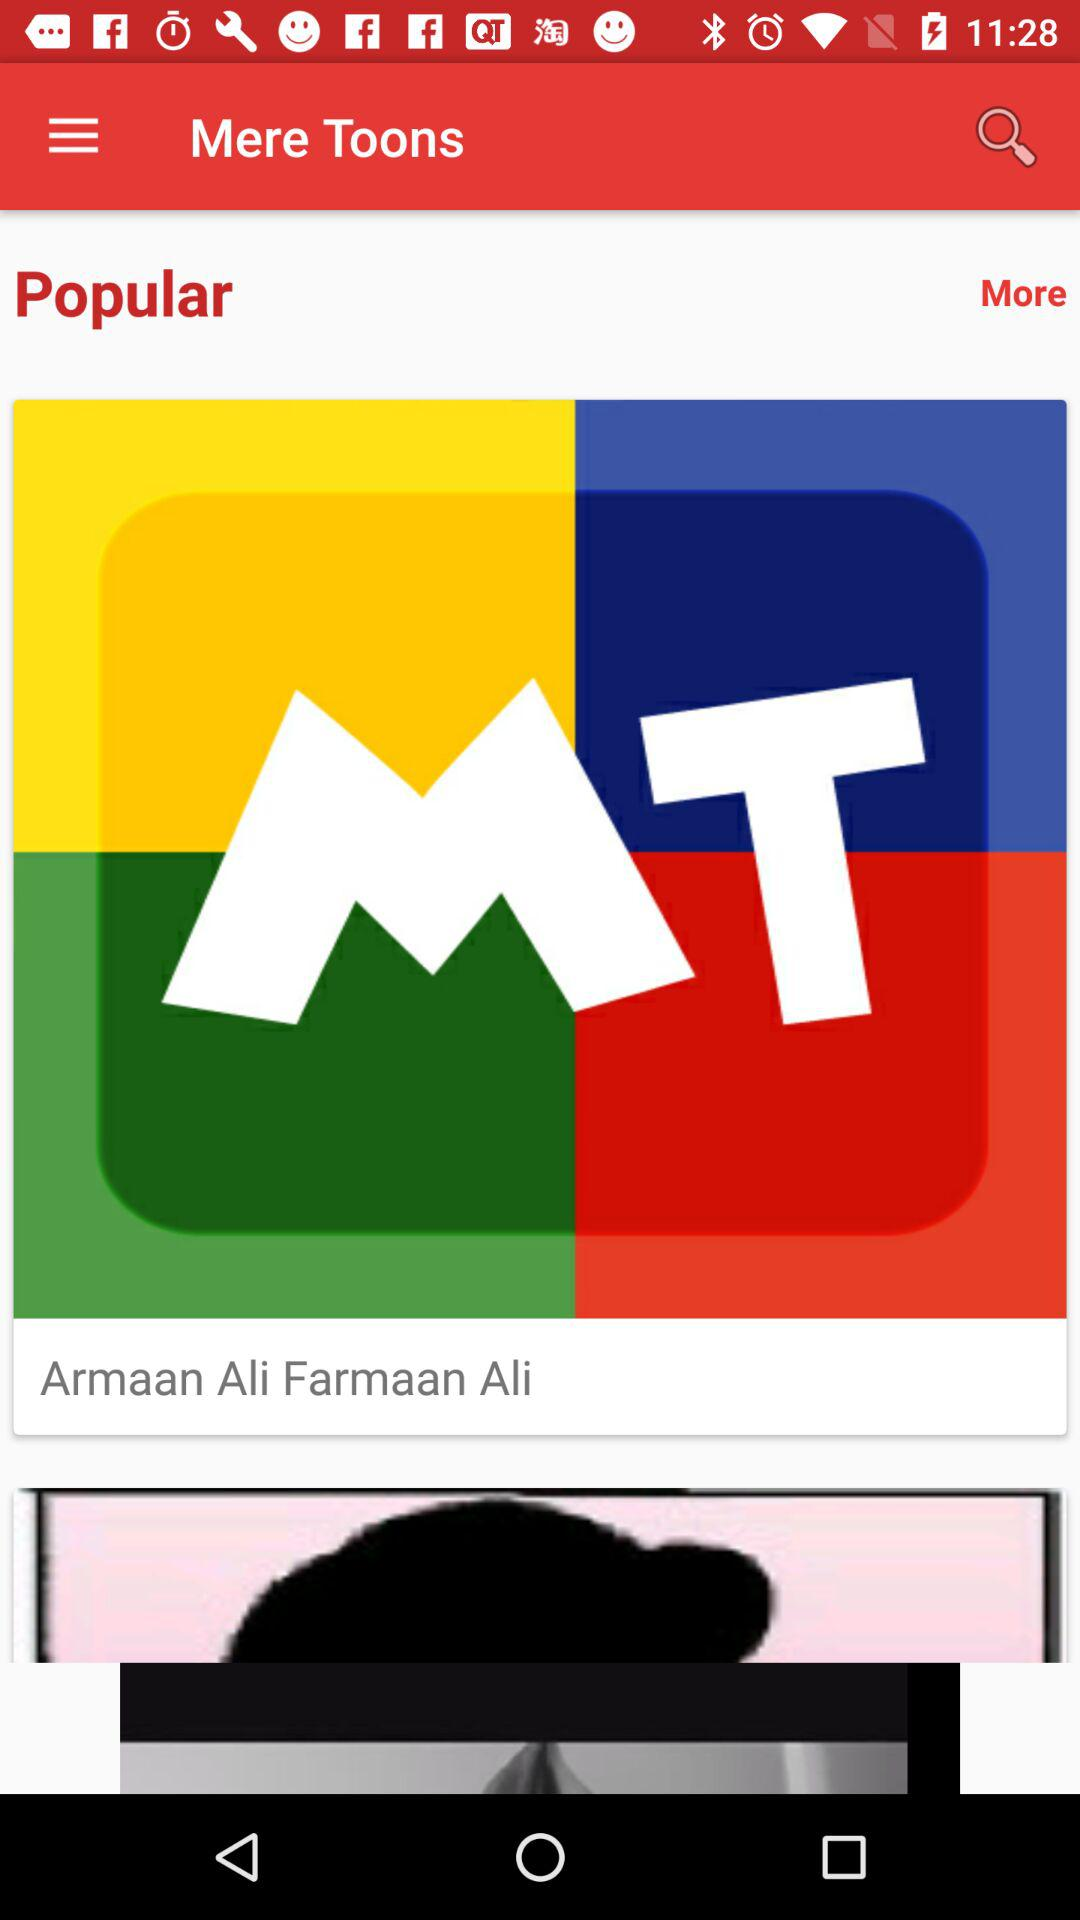What is the name of the application? The name of the application is "Mere Toons". 